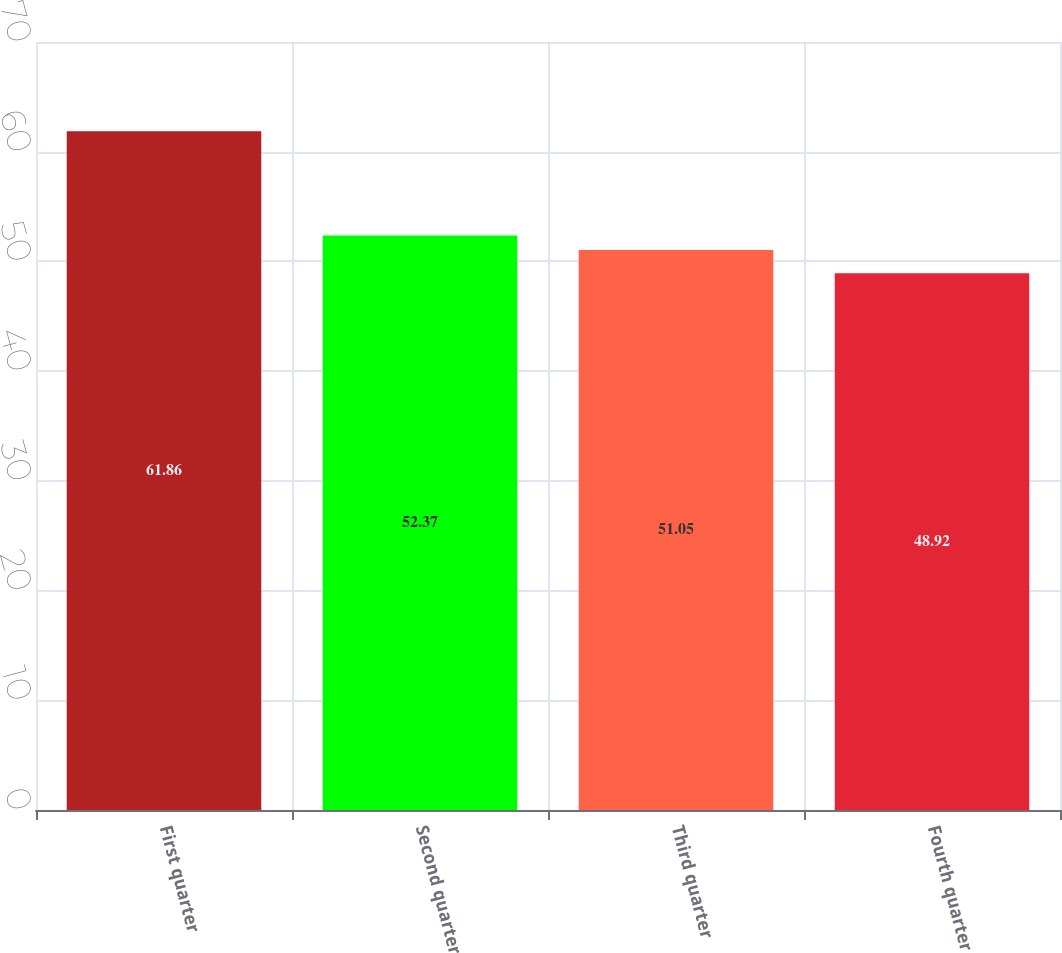<chart> <loc_0><loc_0><loc_500><loc_500><bar_chart><fcel>First quarter<fcel>Second quarter<fcel>Third quarter<fcel>Fourth quarter<nl><fcel>61.86<fcel>52.37<fcel>51.05<fcel>48.92<nl></chart> 